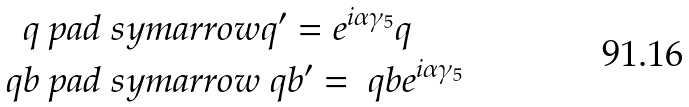<formula> <loc_0><loc_0><loc_500><loc_500>q & \ p a d { \ s y m a r r o w } q ^ { \prime } = e ^ { i \alpha \gamma _ { 5 } } q \\ \ q b & \ p a d { \ s y m a r r o w } \ q b ^ { \prime } = \ q b e ^ { i \alpha \gamma _ { 5 } }</formula> 